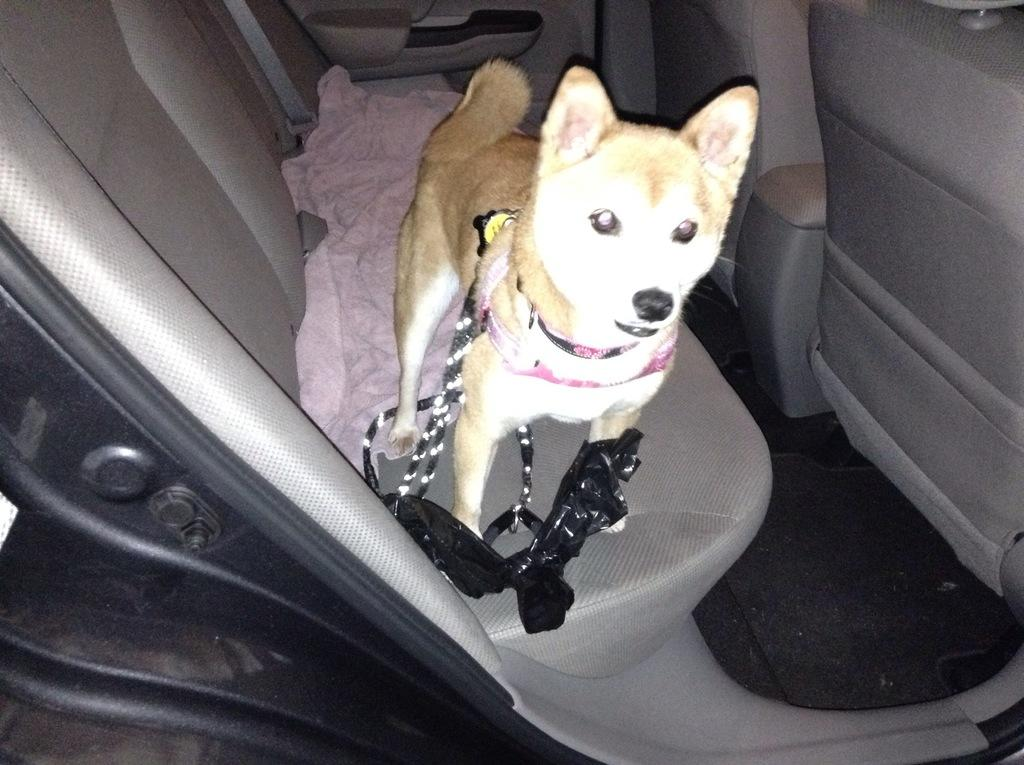What animal is present in the image? There is a dog in the image. What is the dog doing in the image? The dog is standing in a car seat. Is there anything connected to the dog in the image? Yes, there is a string attached to the dog. What type of mitten is the dog wearing on its paw in the image? There is no mitten present on the dog's paw in the image. What kind of record is the dog playing in the image? There is no record present in the image. What type of beast is depicted in the image? The image does not depict any beast; it features a dog standing in a car seat. 